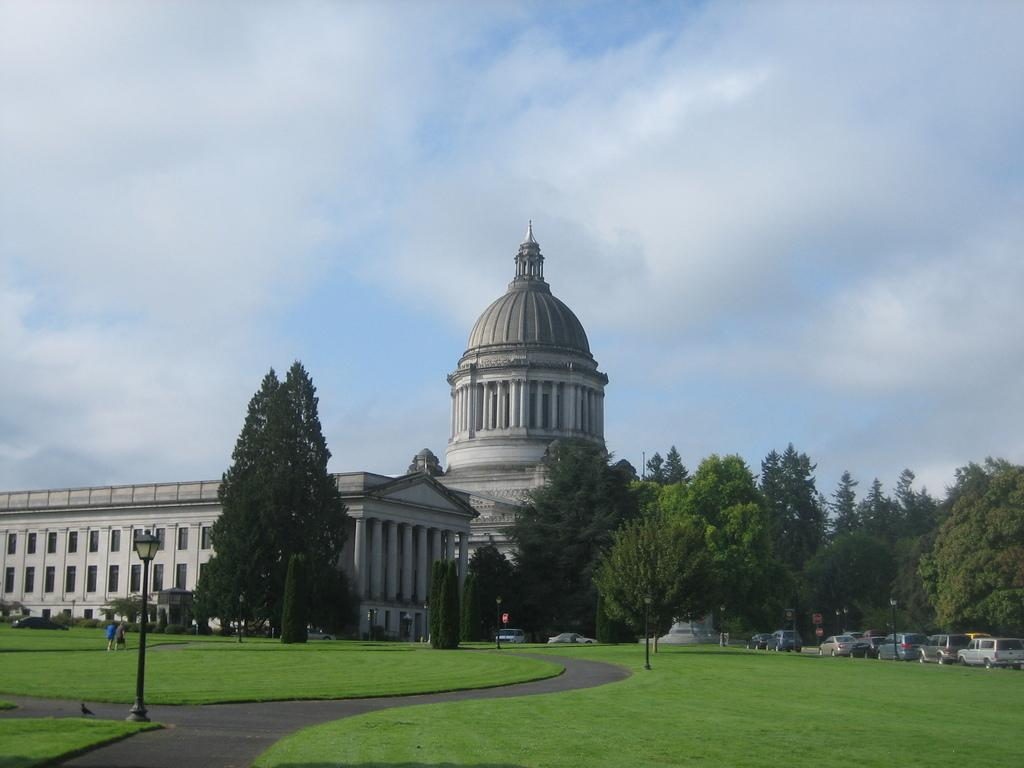What can be seen in the foreground of the picture? In the foreground of the picture, there are street lights, grass, a path, and a bird. What is located in the center of the picture? In the center of the picture, there are trees, plants, cats, and a building. How is the sky depicted in the image? The sky is depicted as cloudy in the image. Can you tell me how many tomatoes are being marked by the cats in the center of the image? There are no tomatoes or marking activity present in the image. How does the bird in the foreground of the picture turn around without using its wings? The bird in the image is stationary and does not turn around. Birds typically use their wings to fly and change direction. 